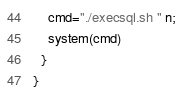Convert code to text. <code><loc_0><loc_0><loc_500><loc_500><_Awk_>    cmd="./execsql.sh " n;
    system(cmd)
  }
}
</code> 